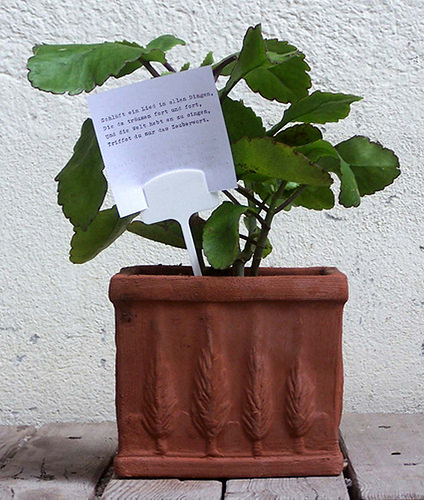<image>
Is the leaf in front of the paper? No. The leaf is not in front of the paper. The spatial positioning shows a different relationship between these objects. 